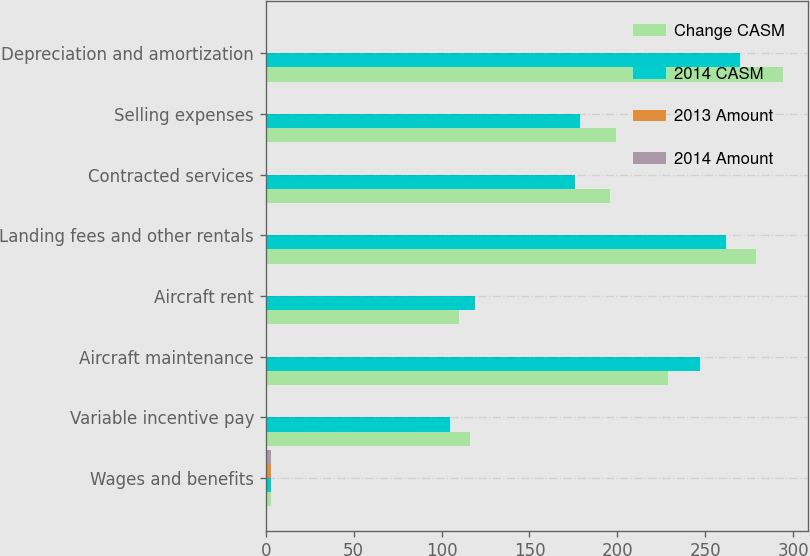Convert chart to OTSL. <chart><loc_0><loc_0><loc_500><loc_500><stacked_bar_chart><ecel><fcel>Wages and benefits<fcel>Variable incentive pay<fcel>Aircraft maintenance<fcel>Aircraft rent<fcel>Landing fees and other rentals<fcel>Contracted services<fcel>Selling expenses<fcel>Depreciation and amortization<nl><fcel>Change CASM<fcel>3.195<fcel>116<fcel>229<fcel>110<fcel>279<fcel>196<fcel>199<fcel>294<nl><fcel>2014 CASM<fcel>3.195<fcel>105<fcel>247<fcel>119<fcel>262<fcel>176<fcel>179<fcel>270<nl><fcel>2013 Amount<fcel>3.16<fcel>0.32<fcel>0.63<fcel>0.3<fcel>0.77<fcel>0.54<fcel>0.55<fcel>0.81<nl><fcel>2014 Amount<fcel>3.23<fcel>0.31<fcel>0.73<fcel>0.35<fcel>0.78<fcel>0.52<fcel>0.53<fcel>0.8<nl></chart> 